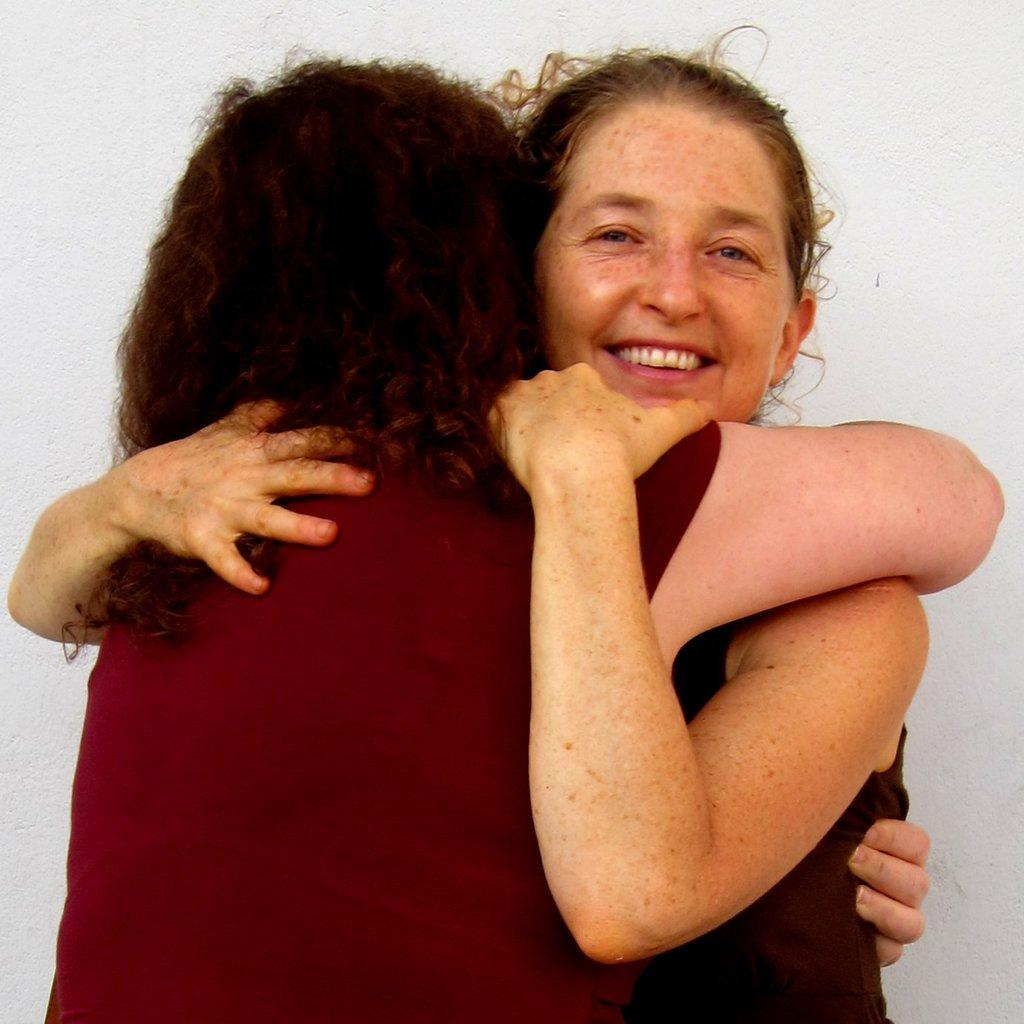How many people are in the image? There are two persons standing in the center of the image. What are the two persons doing? The two persons are hugging. Can you describe the facial expression of one of the persons? One of the persons is smiling. What can be seen in the background of the image? There is a wall in the background of the image. What type of protest is happening in the image? There is no protest present in the image; it features two persons hugging. How many bananas are visible in the image? There are no bananas present in the image. 